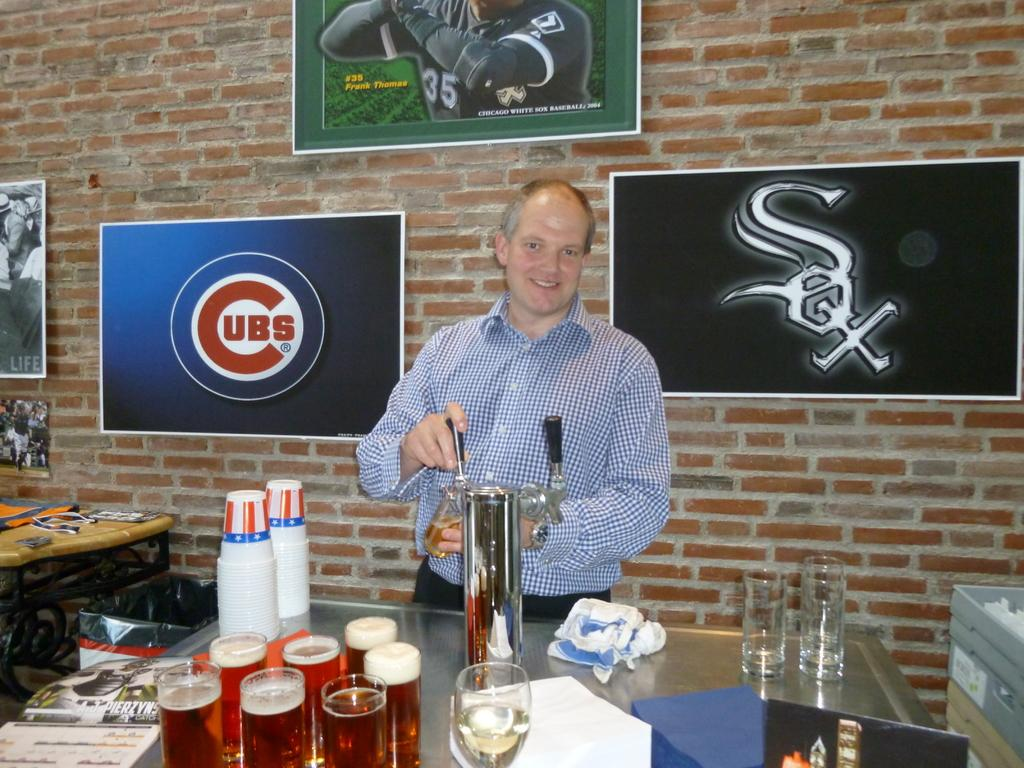<image>
Describe the image concisely. a white male serving bear with a Sox logo in the background 